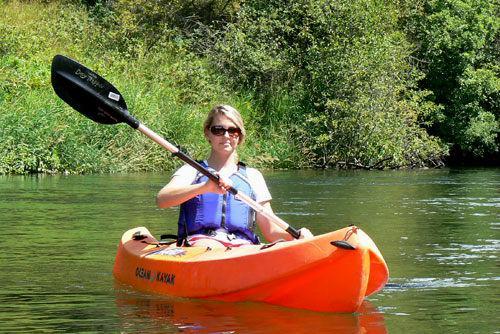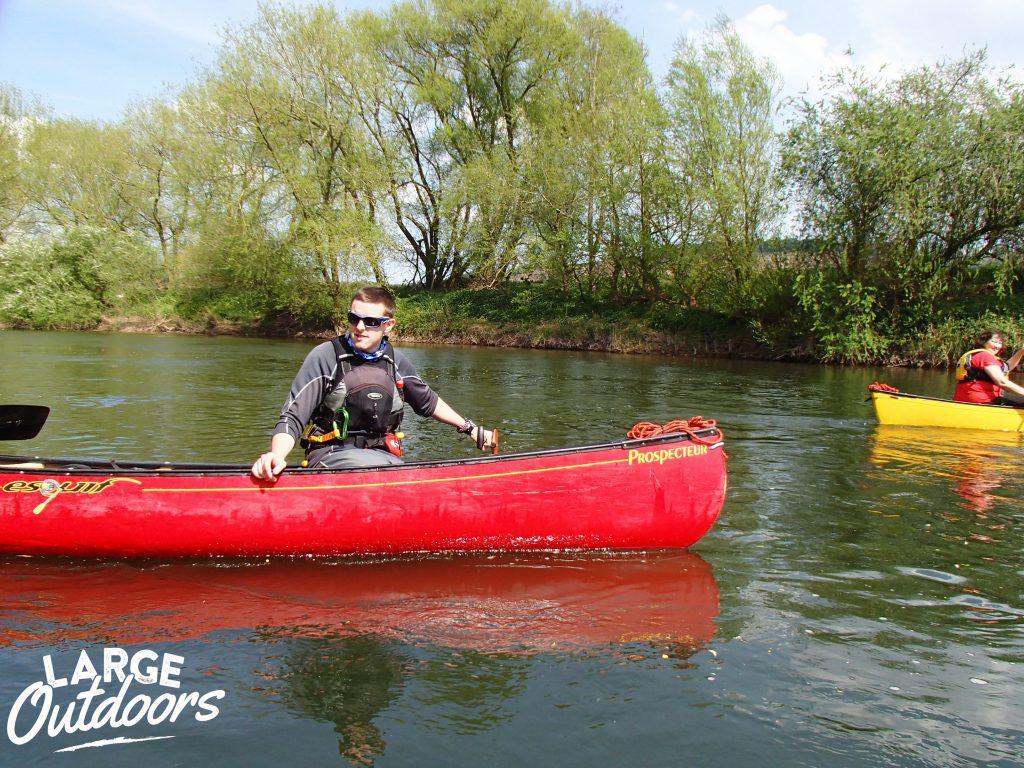The first image is the image on the left, the second image is the image on the right. Analyze the images presented: Is the assertion "An image shows a woman in a life vest and sunglasses holding a raised oar while sitting in a canoe on the water." valid? Answer yes or no. Yes. The first image is the image on the left, the second image is the image on the right. Considering the images on both sides, is "A person is in the water in a red kayak in the image on the right." valid? Answer yes or no. Yes. 